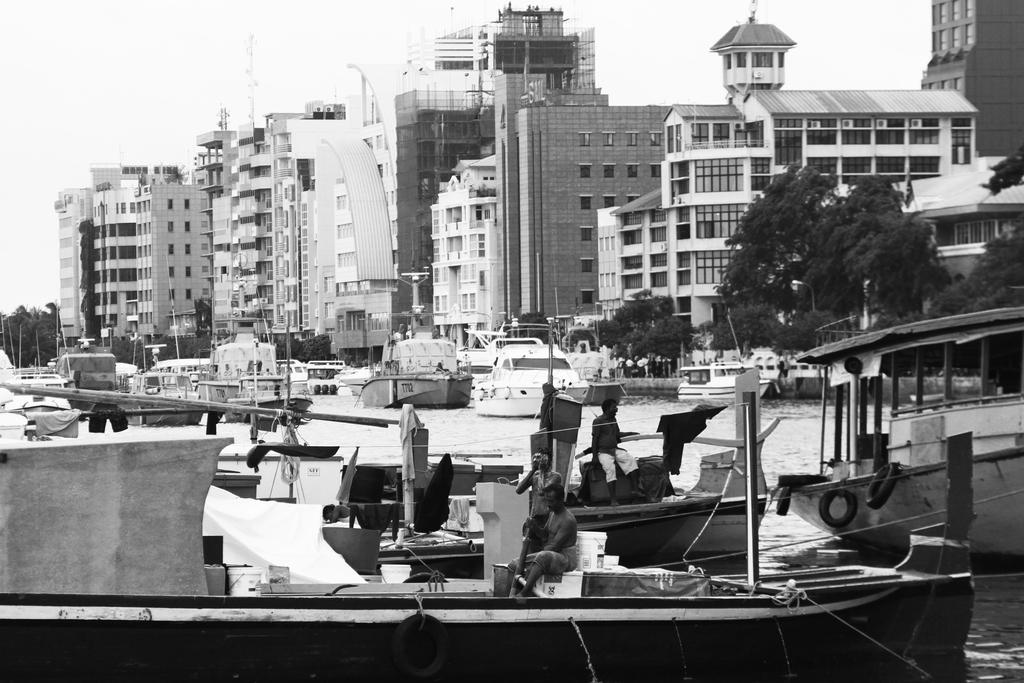What is the color scheme of the image? The image is black and white. What can be seen on the water in the image? There are boats on the water in the image. What are the people in the boat doing? There are persons sitting on the boat. What can be seen in the background of the image? In the background, there are boats, buildings, trees, and the sky. What type of lettuce is being used as a stick to stir the water in the image? There is no lettuce or stirring activity present in the image. 